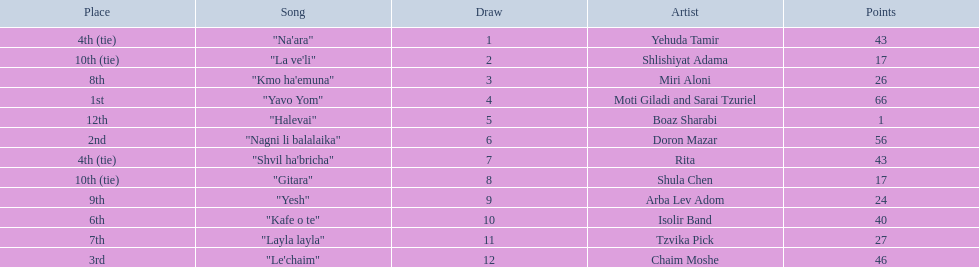What are the points? 43, 17, 26, 66, 1, 56, 43, 17, 24, 40, 27, 46. What is the least? 1. Which artist has that much Boaz Sharabi. 